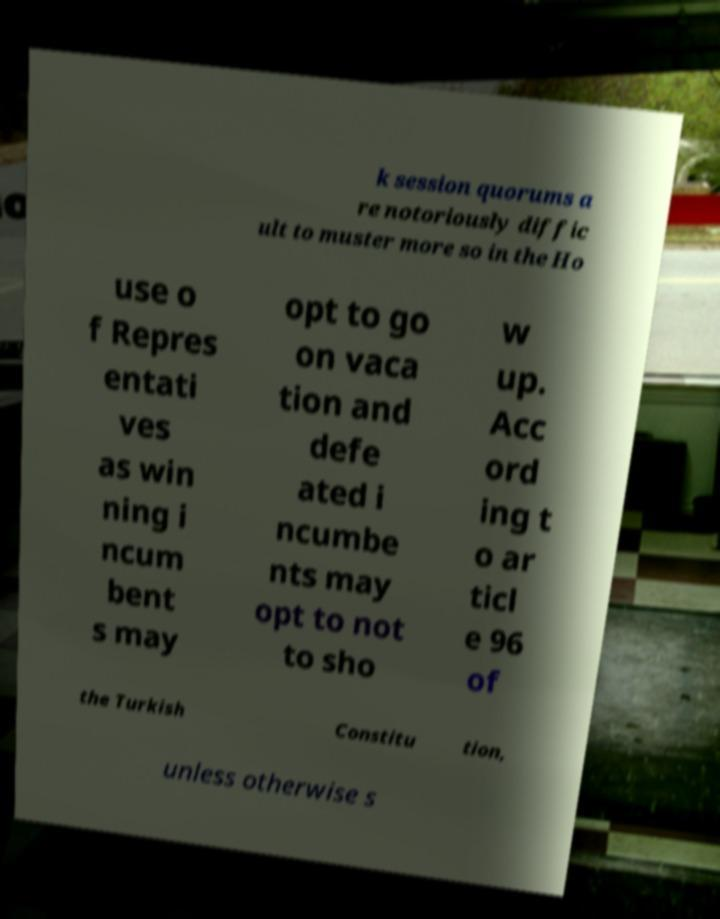Could you assist in decoding the text presented in this image and type it out clearly? k session quorums a re notoriously diffic ult to muster more so in the Ho use o f Repres entati ves as win ning i ncum bent s may opt to go on vaca tion and defe ated i ncumbe nts may opt to not to sho w up. Acc ord ing t o ar ticl e 96 of the Turkish Constitu tion, unless otherwise s 